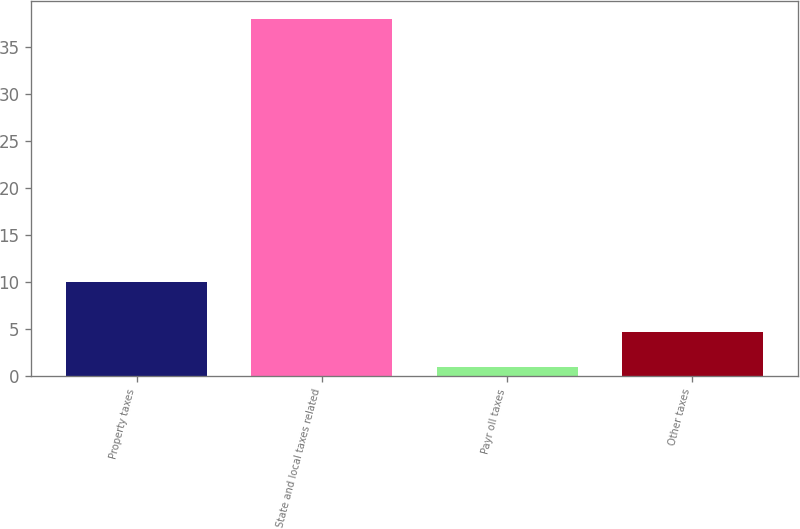Convert chart. <chart><loc_0><loc_0><loc_500><loc_500><bar_chart><fcel>Property taxes<fcel>State and local taxes related<fcel>Payr oll taxes<fcel>Other taxes<nl><fcel>10<fcel>38<fcel>1<fcel>4.7<nl></chart> 